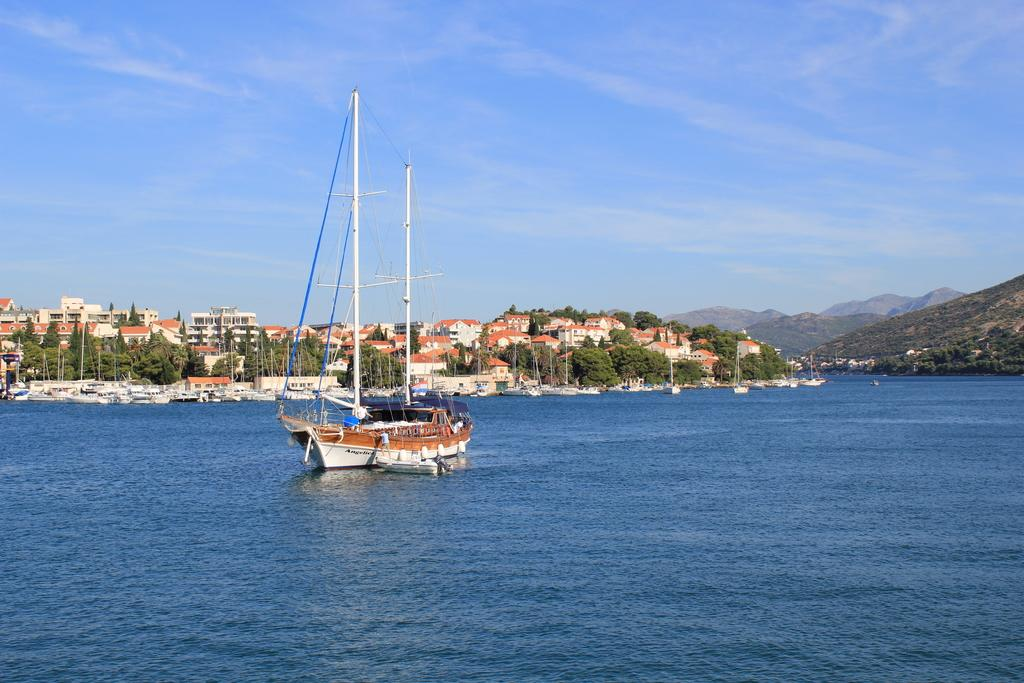What is on the water in the image? There are boats on the water in the image. What can be seen in the background of the image? There are trees, buildings, hills, and clouds visible in the background of the image. Where is the frog sitting during the feast in the image? There is no frog present in the image, and no feast is depicted. 